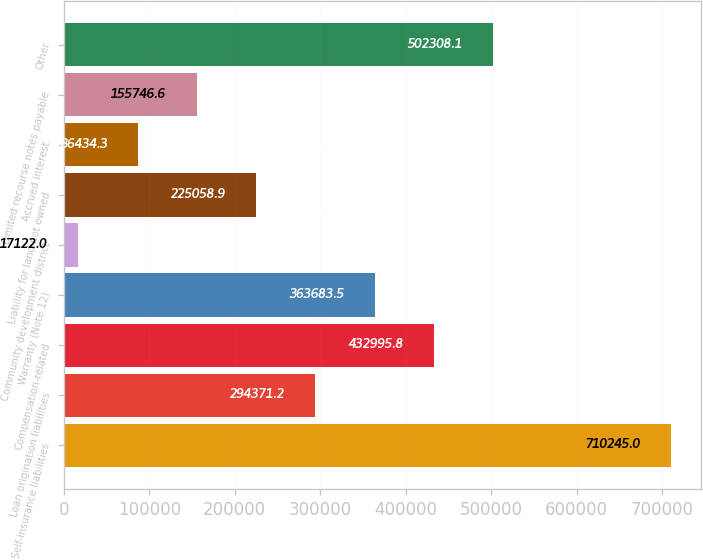Convert chart. <chart><loc_0><loc_0><loc_500><loc_500><bar_chart><fcel>Self-insurance liabilities<fcel>Loan origination liabilities<fcel>Compensation-related<fcel>Warranty (Note 12)<fcel>Community development district<fcel>Liability for land not owned<fcel>Accrued interest<fcel>Limited recourse notes payable<fcel>Other<nl><fcel>710245<fcel>294371<fcel>432996<fcel>363684<fcel>17122<fcel>225059<fcel>86434.3<fcel>155747<fcel>502308<nl></chart> 